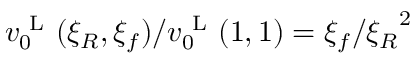<formula> <loc_0><loc_0><loc_500><loc_500>v _ { 0 } ^ { L } ( \xi _ { R } , \xi _ { f } ) / v _ { 0 } ^ { L } ( 1 , 1 ) = \xi _ { f } / { \xi _ { R } } ^ { 2 }</formula> 